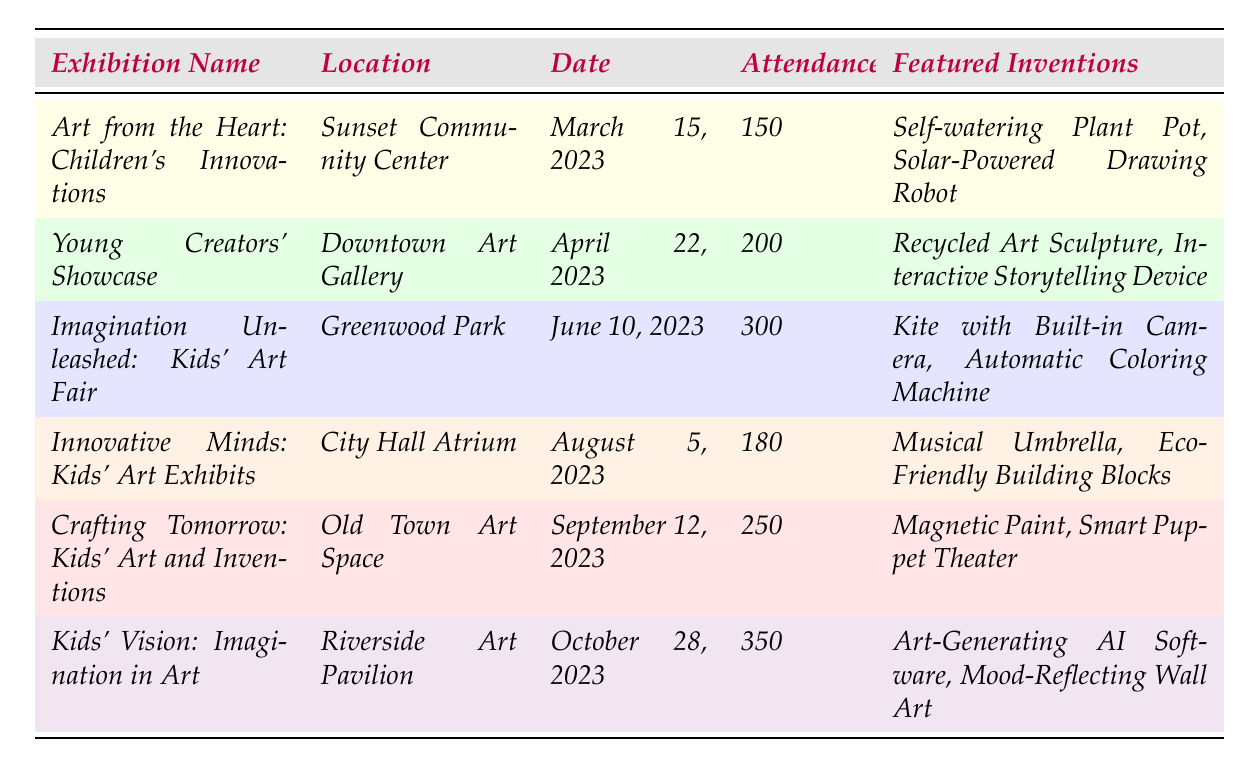What is the name of the exhibition with the highest attendance? The table shows the attendance for each exhibition, and the highest number is 350 for the "Kids' Vision: Imagination in Art."
Answer: Kids' Vision: Imagination in Art Which exhibition took place in the Sunset Community Center? From the table, the exhibition held in the Sunset Community Center is "Art from the Heart: Children's Innovations."
Answer: Art from the Heart: Children's Innovations What was the attendance at the "Crafting Tomorrow: Kids' Art and Inventions"? The attendance for this exhibition is specifically listed in the table as 250.
Answer: 250 How many exhibitions had an attendance of over 200? By analyzing the attendance data, the exhibitions with over 200 attendees are: "Imagination Unleashed: Kids' Art Fair" (300), "Crafting Tomorrow: Kids' Art and Inventions" (250), and "Kids' Vision: Imagination in Art" (350). That's a total of 3 exhibitions.
Answer: 3 What is the date of the exhibition that featured the "Musical Umbrella"? The table states that the "Musical Umbrella" was featured in the "Innovative Minds: Kids' Art Exhibits," which took place on August 5, 2023.
Answer: August 5, 2023 What was the total attendance for "Art from the Heart: Children's Innovations" and "Young Creators' Showcase"? The attendance for "Art from the Heart" is 150, and for "Young Creators' Showcase" it's 200. Adding them gives us 150 + 200 = 350.
Answer: 350 Is the "Kite with Built-in Camera" featured in an exhibition on or before June 10? The "Kite with Built-in Camera" is listed under the "Imagination Unleashed: Kids' Art Fair," which took place on June 10, 2023. Thus, it is true that this invention was featured by that date.
Answer: Yes Which exhibition has the least attendance, and what is that number? The lowest attendance figure in the table is 150 for the exhibition "Art from the Heart: Children's Innovations."
Answer: 150 What was the average attendance across all exhibitions listed? The total attendance is (150 + 200 + 300 + 180 + 250 + 350) = 1430. There are 6 exhibitions, so the average is 1430/6 = 238.33, which can be rounded to 238 when only the whole number is needed.
Answer: 238 How many inventions were featured in the "Kids' Vision: Imagination in Art"? The table lists the featured inventions for "Kids' Vision: Imagination in Art" as "Art-Generating AI Software, Mood-Reflecting Wall Art," totaling 2 inventions.
Answer: 2 